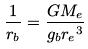<formula> <loc_0><loc_0><loc_500><loc_500>\frac { 1 } { r _ { b } } = \frac { G M _ { e } } { g _ { b } { r _ { e } } ^ { 3 } }</formula> 